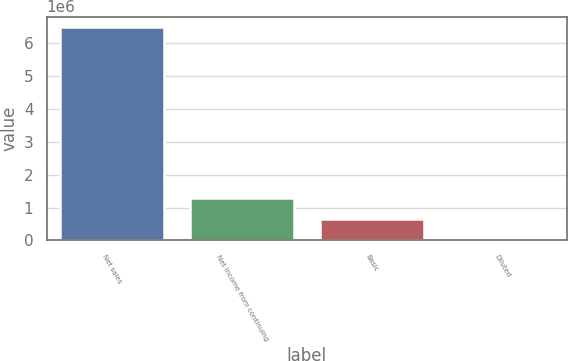Convert chart to OTSL. <chart><loc_0><loc_0><loc_500><loc_500><bar_chart><fcel>Net sales<fcel>Net income from continuing<fcel>Basic<fcel>Diluted<nl><fcel>6.48015e+06<fcel>1.29603e+06<fcel>648016<fcel>1.08<nl></chart> 